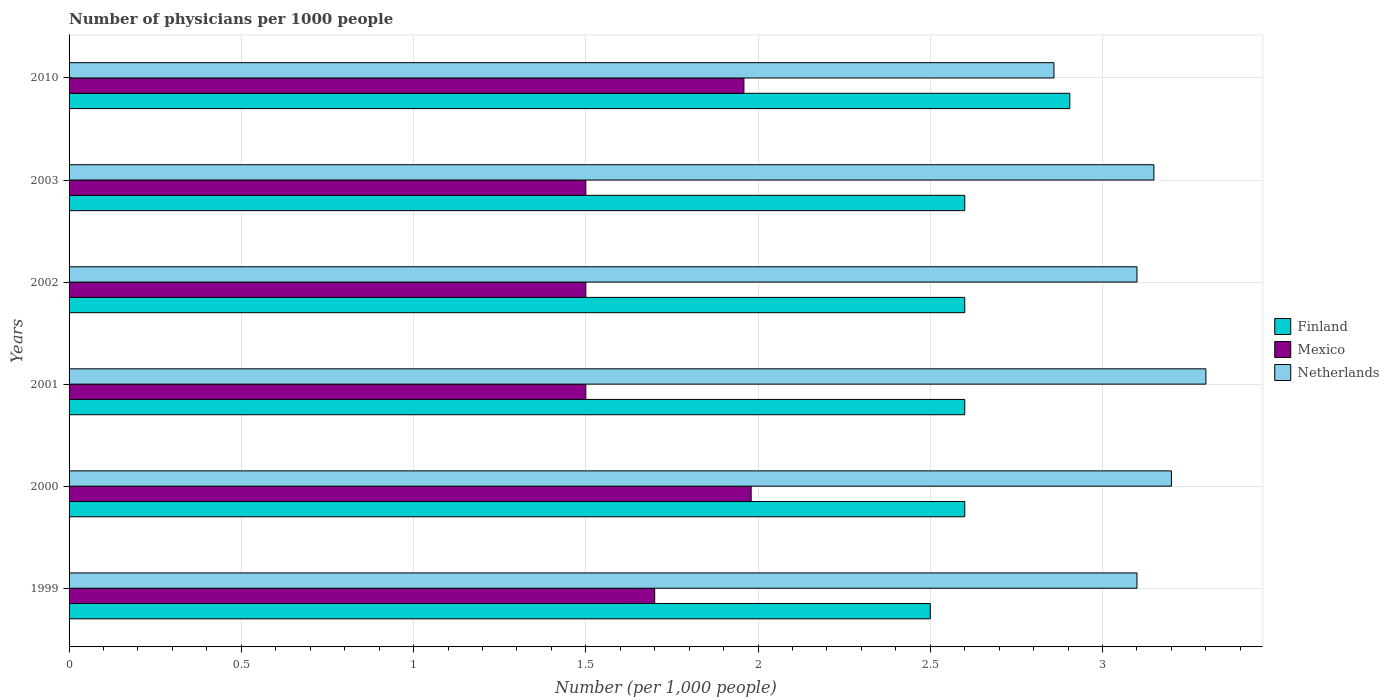How many groups of bars are there?
Provide a succinct answer. 6. Are the number of bars per tick equal to the number of legend labels?
Keep it short and to the point. Yes. How many bars are there on the 5th tick from the bottom?
Offer a terse response. 3. What is the label of the 3rd group of bars from the top?
Your answer should be very brief. 2002. In how many cases, is the number of bars for a given year not equal to the number of legend labels?
Give a very brief answer. 0. Across all years, what is the maximum number of physicians in Mexico?
Your response must be concise. 1.98. Across all years, what is the minimum number of physicians in Finland?
Give a very brief answer. 2.5. In which year was the number of physicians in Mexico maximum?
Give a very brief answer. 2000. In which year was the number of physicians in Netherlands minimum?
Provide a succinct answer. 2010. What is the total number of physicians in Mexico in the graph?
Ensure brevity in your answer.  10.14. What is the difference between the number of physicians in Netherlands in 1999 and that in 2003?
Your answer should be very brief. -0.05. What is the difference between the number of physicians in Mexico in 2000 and the number of physicians in Netherlands in 2001?
Your answer should be compact. -1.32. What is the average number of physicians in Netherlands per year?
Ensure brevity in your answer.  3.12. What is the ratio of the number of physicians in Netherlands in 1999 to that in 2001?
Provide a short and direct response. 0.94. Is the difference between the number of physicians in Finland in 2000 and 2003 greater than the difference between the number of physicians in Mexico in 2000 and 2003?
Provide a succinct answer. No. What is the difference between the highest and the second highest number of physicians in Netherlands?
Provide a succinct answer. 0.1. What is the difference between the highest and the lowest number of physicians in Netherlands?
Offer a very short reply. 0.44. What does the 2nd bar from the bottom in 2010 represents?
Offer a terse response. Mexico. Is it the case that in every year, the sum of the number of physicians in Mexico and number of physicians in Finland is greater than the number of physicians in Netherlands?
Your response must be concise. Yes. How many bars are there?
Make the answer very short. 18. Are all the bars in the graph horizontal?
Your response must be concise. Yes. How many years are there in the graph?
Your answer should be compact. 6. What is the difference between two consecutive major ticks on the X-axis?
Make the answer very short. 0.5. Are the values on the major ticks of X-axis written in scientific E-notation?
Offer a very short reply. No. Does the graph contain any zero values?
Offer a very short reply. No. Where does the legend appear in the graph?
Offer a very short reply. Center right. How many legend labels are there?
Keep it short and to the point. 3. What is the title of the graph?
Give a very brief answer. Number of physicians per 1000 people. What is the label or title of the X-axis?
Ensure brevity in your answer.  Number (per 1,0 people). What is the label or title of the Y-axis?
Offer a terse response. Years. What is the Number (per 1,000 people) in Finland in 1999?
Give a very brief answer. 2.5. What is the Number (per 1,000 people) of Mexico in 1999?
Offer a terse response. 1.7. What is the Number (per 1,000 people) in Netherlands in 1999?
Make the answer very short. 3.1. What is the Number (per 1,000 people) of Mexico in 2000?
Ensure brevity in your answer.  1.98. What is the Number (per 1,000 people) of Netherlands in 2000?
Offer a terse response. 3.2. What is the Number (per 1,000 people) of Finland in 2001?
Offer a terse response. 2.6. What is the Number (per 1,000 people) of Mexico in 2001?
Offer a terse response. 1.5. What is the Number (per 1,000 people) of Netherlands in 2001?
Offer a very short reply. 3.3. What is the Number (per 1,000 people) of Finland in 2002?
Ensure brevity in your answer.  2.6. What is the Number (per 1,000 people) of Netherlands in 2002?
Your answer should be compact. 3.1. What is the Number (per 1,000 people) of Finland in 2003?
Provide a succinct answer. 2.6. What is the Number (per 1,000 people) of Mexico in 2003?
Ensure brevity in your answer.  1.5. What is the Number (per 1,000 people) in Netherlands in 2003?
Provide a short and direct response. 3.15. What is the Number (per 1,000 people) in Finland in 2010?
Ensure brevity in your answer.  2.9. What is the Number (per 1,000 people) of Mexico in 2010?
Your response must be concise. 1.96. What is the Number (per 1,000 people) of Netherlands in 2010?
Offer a very short reply. 2.86. Across all years, what is the maximum Number (per 1,000 people) of Finland?
Offer a very short reply. 2.9. Across all years, what is the maximum Number (per 1,000 people) in Mexico?
Your response must be concise. 1.98. Across all years, what is the minimum Number (per 1,000 people) in Finland?
Offer a terse response. 2.5. Across all years, what is the minimum Number (per 1,000 people) of Netherlands?
Provide a succinct answer. 2.86. What is the total Number (per 1,000 people) in Finland in the graph?
Give a very brief answer. 15.8. What is the total Number (per 1,000 people) in Mexico in the graph?
Keep it short and to the point. 10.14. What is the total Number (per 1,000 people) of Netherlands in the graph?
Your response must be concise. 18.71. What is the difference between the Number (per 1,000 people) in Finland in 1999 and that in 2000?
Offer a terse response. -0.1. What is the difference between the Number (per 1,000 people) of Mexico in 1999 and that in 2000?
Provide a succinct answer. -0.28. What is the difference between the Number (per 1,000 people) of Mexico in 1999 and that in 2002?
Offer a terse response. 0.2. What is the difference between the Number (per 1,000 people) in Mexico in 1999 and that in 2003?
Ensure brevity in your answer.  0.2. What is the difference between the Number (per 1,000 people) in Netherlands in 1999 and that in 2003?
Your answer should be very brief. -0.05. What is the difference between the Number (per 1,000 people) in Finland in 1999 and that in 2010?
Keep it short and to the point. -0.41. What is the difference between the Number (per 1,000 people) in Mexico in 1999 and that in 2010?
Make the answer very short. -0.26. What is the difference between the Number (per 1,000 people) of Netherlands in 1999 and that in 2010?
Your answer should be compact. 0.24. What is the difference between the Number (per 1,000 people) of Mexico in 2000 and that in 2001?
Offer a terse response. 0.48. What is the difference between the Number (per 1,000 people) of Finland in 2000 and that in 2002?
Your answer should be very brief. 0. What is the difference between the Number (per 1,000 people) in Mexico in 2000 and that in 2002?
Offer a very short reply. 0.48. What is the difference between the Number (per 1,000 people) of Finland in 2000 and that in 2003?
Your answer should be very brief. 0. What is the difference between the Number (per 1,000 people) of Mexico in 2000 and that in 2003?
Give a very brief answer. 0.48. What is the difference between the Number (per 1,000 people) of Netherlands in 2000 and that in 2003?
Your answer should be compact. 0.05. What is the difference between the Number (per 1,000 people) in Finland in 2000 and that in 2010?
Offer a terse response. -0.3. What is the difference between the Number (per 1,000 people) in Mexico in 2000 and that in 2010?
Your response must be concise. 0.02. What is the difference between the Number (per 1,000 people) in Netherlands in 2000 and that in 2010?
Offer a very short reply. 0.34. What is the difference between the Number (per 1,000 people) of Finland in 2001 and that in 2003?
Your answer should be compact. 0. What is the difference between the Number (per 1,000 people) of Netherlands in 2001 and that in 2003?
Your answer should be very brief. 0.15. What is the difference between the Number (per 1,000 people) in Finland in 2001 and that in 2010?
Your answer should be very brief. -0.3. What is the difference between the Number (per 1,000 people) of Mexico in 2001 and that in 2010?
Your answer should be very brief. -0.46. What is the difference between the Number (per 1,000 people) in Netherlands in 2001 and that in 2010?
Make the answer very short. 0.44. What is the difference between the Number (per 1,000 people) of Netherlands in 2002 and that in 2003?
Give a very brief answer. -0.05. What is the difference between the Number (per 1,000 people) of Finland in 2002 and that in 2010?
Your response must be concise. -0.3. What is the difference between the Number (per 1,000 people) of Mexico in 2002 and that in 2010?
Ensure brevity in your answer.  -0.46. What is the difference between the Number (per 1,000 people) in Netherlands in 2002 and that in 2010?
Provide a succinct answer. 0.24. What is the difference between the Number (per 1,000 people) in Finland in 2003 and that in 2010?
Provide a short and direct response. -0.3. What is the difference between the Number (per 1,000 people) of Mexico in 2003 and that in 2010?
Your answer should be very brief. -0.46. What is the difference between the Number (per 1,000 people) of Netherlands in 2003 and that in 2010?
Offer a terse response. 0.29. What is the difference between the Number (per 1,000 people) in Finland in 1999 and the Number (per 1,000 people) in Mexico in 2000?
Provide a short and direct response. 0.52. What is the difference between the Number (per 1,000 people) in Mexico in 1999 and the Number (per 1,000 people) in Netherlands in 2000?
Your answer should be compact. -1.5. What is the difference between the Number (per 1,000 people) in Finland in 1999 and the Number (per 1,000 people) in Mexico in 2001?
Ensure brevity in your answer.  1. What is the difference between the Number (per 1,000 people) of Mexico in 1999 and the Number (per 1,000 people) of Netherlands in 2001?
Give a very brief answer. -1.6. What is the difference between the Number (per 1,000 people) of Finland in 1999 and the Number (per 1,000 people) of Mexico in 2002?
Your answer should be compact. 1. What is the difference between the Number (per 1,000 people) in Finland in 1999 and the Number (per 1,000 people) in Mexico in 2003?
Provide a short and direct response. 1. What is the difference between the Number (per 1,000 people) of Finland in 1999 and the Number (per 1,000 people) of Netherlands in 2003?
Give a very brief answer. -0.65. What is the difference between the Number (per 1,000 people) in Mexico in 1999 and the Number (per 1,000 people) in Netherlands in 2003?
Provide a short and direct response. -1.45. What is the difference between the Number (per 1,000 people) of Finland in 1999 and the Number (per 1,000 people) of Mexico in 2010?
Ensure brevity in your answer.  0.54. What is the difference between the Number (per 1,000 people) in Finland in 1999 and the Number (per 1,000 people) in Netherlands in 2010?
Keep it short and to the point. -0.36. What is the difference between the Number (per 1,000 people) in Mexico in 1999 and the Number (per 1,000 people) in Netherlands in 2010?
Offer a terse response. -1.16. What is the difference between the Number (per 1,000 people) of Mexico in 2000 and the Number (per 1,000 people) of Netherlands in 2001?
Your answer should be compact. -1.32. What is the difference between the Number (per 1,000 people) in Finland in 2000 and the Number (per 1,000 people) in Mexico in 2002?
Give a very brief answer. 1.1. What is the difference between the Number (per 1,000 people) of Mexico in 2000 and the Number (per 1,000 people) of Netherlands in 2002?
Provide a short and direct response. -1.12. What is the difference between the Number (per 1,000 people) in Finland in 2000 and the Number (per 1,000 people) in Mexico in 2003?
Your response must be concise. 1.1. What is the difference between the Number (per 1,000 people) of Finland in 2000 and the Number (per 1,000 people) of Netherlands in 2003?
Keep it short and to the point. -0.55. What is the difference between the Number (per 1,000 people) in Mexico in 2000 and the Number (per 1,000 people) in Netherlands in 2003?
Provide a succinct answer. -1.17. What is the difference between the Number (per 1,000 people) in Finland in 2000 and the Number (per 1,000 people) in Mexico in 2010?
Offer a very short reply. 0.64. What is the difference between the Number (per 1,000 people) in Finland in 2000 and the Number (per 1,000 people) in Netherlands in 2010?
Provide a succinct answer. -0.26. What is the difference between the Number (per 1,000 people) in Mexico in 2000 and the Number (per 1,000 people) in Netherlands in 2010?
Your response must be concise. -0.88. What is the difference between the Number (per 1,000 people) in Finland in 2001 and the Number (per 1,000 people) in Mexico in 2002?
Your response must be concise. 1.1. What is the difference between the Number (per 1,000 people) of Finland in 2001 and the Number (per 1,000 people) of Netherlands in 2002?
Provide a short and direct response. -0.5. What is the difference between the Number (per 1,000 people) of Finland in 2001 and the Number (per 1,000 people) of Mexico in 2003?
Keep it short and to the point. 1.1. What is the difference between the Number (per 1,000 people) in Finland in 2001 and the Number (per 1,000 people) in Netherlands in 2003?
Your answer should be very brief. -0.55. What is the difference between the Number (per 1,000 people) of Mexico in 2001 and the Number (per 1,000 people) of Netherlands in 2003?
Keep it short and to the point. -1.65. What is the difference between the Number (per 1,000 people) in Finland in 2001 and the Number (per 1,000 people) in Mexico in 2010?
Give a very brief answer. 0.64. What is the difference between the Number (per 1,000 people) of Finland in 2001 and the Number (per 1,000 people) of Netherlands in 2010?
Provide a short and direct response. -0.26. What is the difference between the Number (per 1,000 people) of Mexico in 2001 and the Number (per 1,000 people) of Netherlands in 2010?
Your response must be concise. -1.36. What is the difference between the Number (per 1,000 people) in Finland in 2002 and the Number (per 1,000 people) in Mexico in 2003?
Make the answer very short. 1.1. What is the difference between the Number (per 1,000 people) in Finland in 2002 and the Number (per 1,000 people) in Netherlands in 2003?
Your answer should be compact. -0.55. What is the difference between the Number (per 1,000 people) of Mexico in 2002 and the Number (per 1,000 people) of Netherlands in 2003?
Your answer should be very brief. -1.65. What is the difference between the Number (per 1,000 people) of Finland in 2002 and the Number (per 1,000 people) of Mexico in 2010?
Provide a succinct answer. 0.64. What is the difference between the Number (per 1,000 people) of Finland in 2002 and the Number (per 1,000 people) of Netherlands in 2010?
Keep it short and to the point. -0.26. What is the difference between the Number (per 1,000 people) of Mexico in 2002 and the Number (per 1,000 people) of Netherlands in 2010?
Provide a short and direct response. -1.36. What is the difference between the Number (per 1,000 people) of Finland in 2003 and the Number (per 1,000 people) of Mexico in 2010?
Offer a terse response. 0.64. What is the difference between the Number (per 1,000 people) of Finland in 2003 and the Number (per 1,000 people) of Netherlands in 2010?
Make the answer very short. -0.26. What is the difference between the Number (per 1,000 people) of Mexico in 2003 and the Number (per 1,000 people) of Netherlands in 2010?
Your answer should be compact. -1.36. What is the average Number (per 1,000 people) in Finland per year?
Make the answer very short. 2.63. What is the average Number (per 1,000 people) in Mexico per year?
Provide a short and direct response. 1.69. What is the average Number (per 1,000 people) of Netherlands per year?
Make the answer very short. 3.12. In the year 1999, what is the difference between the Number (per 1,000 people) in Mexico and Number (per 1,000 people) in Netherlands?
Provide a short and direct response. -1.4. In the year 2000, what is the difference between the Number (per 1,000 people) in Finland and Number (per 1,000 people) in Mexico?
Provide a succinct answer. 0.62. In the year 2000, what is the difference between the Number (per 1,000 people) of Mexico and Number (per 1,000 people) of Netherlands?
Make the answer very short. -1.22. In the year 2001, what is the difference between the Number (per 1,000 people) in Finland and Number (per 1,000 people) in Netherlands?
Offer a very short reply. -0.7. In the year 2002, what is the difference between the Number (per 1,000 people) of Finland and Number (per 1,000 people) of Mexico?
Make the answer very short. 1.1. In the year 2002, what is the difference between the Number (per 1,000 people) of Finland and Number (per 1,000 people) of Netherlands?
Provide a short and direct response. -0.5. In the year 2003, what is the difference between the Number (per 1,000 people) in Finland and Number (per 1,000 people) in Mexico?
Keep it short and to the point. 1.1. In the year 2003, what is the difference between the Number (per 1,000 people) of Finland and Number (per 1,000 people) of Netherlands?
Ensure brevity in your answer.  -0.55. In the year 2003, what is the difference between the Number (per 1,000 people) in Mexico and Number (per 1,000 people) in Netherlands?
Provide a short and direct response. -1.65. In the year 2010, what is the difference between the Number (per 1,000 people) in Finland and Number (per 1,000 people) in Mexico?
Keep it short and to the point. 0.95. In the year 2010, what is the difference between the Number (per 1,000 people) in Finland and Number (per 1,000 people) in Netherlands?
Your answer should be compact. 0.05. What is the ratio of the Number (per 1,000 people) of Finland in 1999 to that in 2000?
Your answer should be compact. 0.96. What is the ratio of the Number (per 1,000 people) in Mexico in 1999 to that in 2000?
Offer a very short reply. 0.86. What is the ratio of the Number (per 1,000 people) of Netherlands in 1999 to that in 2000?
Ensure brevity in your answer.  0.97. What is the ratio of the Number (per 1,000 people) in Finland in 1999 to that in 2001?
Provide a short and direct response. 0.96. What is the ratio of the Number (per 1,000 people) of Mexico in 1999 to that in 2001?
Keep it short and to the point. 1.13. What is the ratio of the Number (per 1,000 people) in Netherlands in 1999 to that in 2001?
Offer a terse response. 0.94. What is the ratio of the Number (per 1,000 people) in Finland in 1999 to that in 2002?
Make the answer very short. 0.96. What is the ratio of the Number (per 1,000 people) of Mexico in 1999 to that in 2002?
Provide a succinct answer. 1.13. What is the ratio of the Number (per 1,000 people) of Netherlands in 1999 to that in 2002?
Ensure brevity in your answer.  1. What is the ratio of the Number (per 1,000 people) of Finland in 1999 to that in 2003?
Your answer should be very brief. 0.96. What is the ratio of the Number (per 1,000 people) in Mexico in 1999 to that in 2003?
Ensure brevity in your answer.  1.13. What is the ratio of the Number (per 1,000 people) of Netherlands in 1999 to that in 2003?
Provide a short and direct response. 0.98. What is the ratio of the Number (per 1,000 people) of Finland in 1999 to that in 2010?
Keep it short and to the point. 0.86. What is the ratio of the Number (per 1,000 people) of Mexico in 1999 to that in 2010?
Your answer should be compact. 0.87. What is the ratio of the Number (per 1,000 people) of Netherlands in 1999 to that in 2010?
Your answer should be very brief. 1.08. What is the ratio of the Number (per 1,000 people) in Finland in 2000 to that in 2001?
Keep it short and to the point. 1. What is the ratio of the Number (per 1,000 people) in Mexico in 2000 to that in 2001?
Your response must be concise. 1.32. What is the ratio of the Number (per 1,000 people) in Netherlands in 2000 to that in 2001?
Offer a terse response. 0.97. What is the ratio of the Number (per 1,000 people) in Finland in 2000 to that in 2002?
Provide a short and direct response. 1. What is the ratio of the Number (per 1,000 people) of Mexico in 2000 to that in 2002?
Make the answer very short. 1.32. What is the ratio of the Number (per 1,000 people) of Netherlands in 2000 to that in 2002?
Your answer should be very brief. 1.03. What is the ratio of the Number (per 1,000 people) in Finland in 2000 to that in 2003?
Provide a short and direct response. 1. What is the ratio of the Number (per 1,000 people) in Mexico in 2000 to that in 2003?
Give a very brief answer. 1.32. What is the ratio of the Number (per 1,000 people) in Netherlands in 2000 to that in 2003?
Provide a short and direct response. 1.02. What is the ratio of the Number (per 1,000 people) of Finland in 2000 to that in 2010?
Keep it short and to the point. 0.9. What is the ratio of the Number (per 1,000 people) in Mexico in 2000 to that in 2010?
Make the answer very short. 1.01. What is the ratio of the Number (per 1,000 people) in Netherlands in 2000 to that in 2010?
Provide a short and direct response. 1.12. What is the ratio of the Number (per 1,000 people) in Finland in 2001 to that in 2002?
Offer a terse response. 1. What is the ratio of the Number (per 1,000 people) in Mexico in 2001 to that in 2002?
Give a very brief answer. 1. What is the ratio of the Number (per 1,000 people) of Netherlands in 2001 to that in 2002?
Give a very brief answer. 1.06. What is the ratio of the Number (per 1,000 people) in Mexico in 2001 to that in 2003?
Your answer should be compact. 1. What is the ratio of the Number (per 1,000 people) in Netherlands in 2001 to that in 2003?
Your answer should be very brief. 1.05. What is the ratio of the Number (per 1,000 people) of Finland in 2001 to that in 2010?
Your answer should be very brief. 0.9. What is the ratio of the Number (per 1,000 people) in Mexico in 2001 to that in 2010?
Offer a very short reply. 0.77. What is the ratio of the Number (per 1,000 people) in Netherlands in 2001 to that in 2010?
Ensure brevity in your answer.  1.15. What is the ratio of the Number (per 1,000 people) in Netherlands in 2002 to that in 2003?
Offer a terse response. 0.98. What is the ratio of the Number (per 1,000 people) in Finland in 2002 to that in 2010?
Your answer should be compact. 0.9. What is the ratio of the Number (per 1,000 people) in Mexico in 2002 to that in 2010?
Provide a succinct answer. 0.77. What is the ratio of the Number (per 1,000 people) of Netherlands in 2002 to that in 2010?
Provide a succinct answer. 1.08. What is the ratio of the Number (per 1,000 people) in Finland in 2003 to that in 2010?
Provide a succinct answer. 0.9. What is the ratio of the Number (per 1,000 people) in Mexico in 2003 to that in 2010?
Your response must be concise. 0.77. What is the ratio of the Number (per 1,000 people) of Netherlands in 2003 to that in 2010?
Offer a terse response. 1.1. What is the difference between the highest and the second highest Number (per 1,000 people) in Finland?
Offer a very short reply. 0.3. What is the difference between the highest and the second highest Number (per 1,000 people) in Mexico?
Your answer should be compact. 0.02. What is the difference between the highest and the second highest Number (per 1,000 people) of Netherlands?
Keep it short and to the point. 0.1. What is the difference between the highest and the lowest Number (per 1,000 people) in Finland?
Provide a short and direct response. 0.41. What is the difference between the highest and the lowest Number (per 1,000 people) of Mexico?
Provide a succinct answer. 0.48. What is the difference between the highest and the lowest Number (per 1,000 people) in Netherlands?
Offer a very short reply. 0.44. 